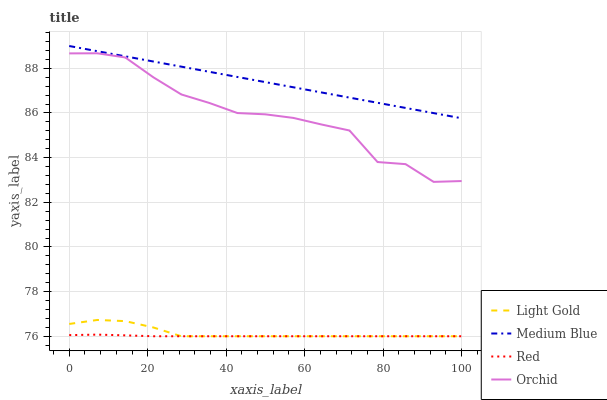Does Red have the minimum area under the curve?
Answer yes or no. Yes. Does Medium Blue have the maximum area under the curve?
Answer yes or no. Yes. Does Light Gold have the minimum area under the curve?
Answer yes or no. No. Does Light Gold have the maximum area under the curve?
Answer yes or no. No. Is Medium Blue the smoothest?
Answer yes or no. Yes. Is Orchid the roughest?
Answer yes or no. Yes. Is Light Gold the smoothest?
Answer yes or no. No. Is Light Gold the roughest?
Answer yes or no. No. Does Light Gold have the lowest value?
Answer yes or no. Yes. Does Orchid have the lowest value?
Answer yes or no. No. Does Medium Blue have the highest value?
Answer yes or no. Yes. Does Light Gold have the highest value?
Answer yes or no. No. Is Light Gold less than Orchid?
Answer yes or no. Yes. Is Orchid greater than Red?
Answer yes or no. Yes. Does Light Gold intersect Red?
Answer yes or no. Yes. Is Light Gold less than Red?
Answer yes or no. No. Is Light Gold greater than Red?
Answer yes or no. No. Does Light Gold intersect Orchid?
Answer yes or no. No. 